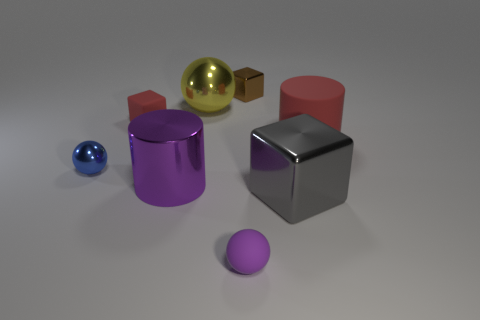What is the material of the gray thing?
Offer a terse response. Metal. What size is the shiny thing that is the same shape as the big rubber thing?
Make the answer very short. Large. What number of other things are the same material as the brown object?
Provide a short and direct response. 4. Is the material of the red cube the same as the cylinder to the right of the big shiny cube?
Provide a succinct answer. Yes. Is the number of small shiny things in front of the tiny purple thing less than the number of cylinders that are on the left side of the big red cylinder?
Offer a terse response. Yes. There is a object in front of the gray metal block; what is its color?
Offer a terse response. Purple. What number of other things are the same color as the rubber cylinder?
Give a very brief answer. 1. Is the size of the red matte thing to the right of the brown shiny cube the same as the big metal cube?
Your response must be concise. Yes. What number of large gray things are on the right side of the yellow object?
Give a very brief answer. 1. Is there a yellow ball of the same size as the red rubber cylinder?
Provide a succinct answer. Yes. 